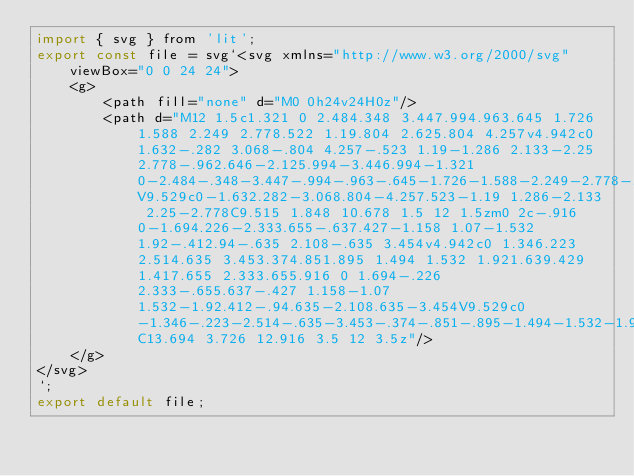Convert code to text. <code><loc_0><loc_0><loc_500><loc_500><_JavaScript_>import { svg } from 'lit';
export const file = svg`<svg xmlns="http://www.w3.org/2000/svg" viewBox="0 0 24 24">
    <g>
        <path fill="none" d="M0 0h24v24H0z"/>
        <path d="M12 1.5c1.321 0 2.484.348 3.447.994.963.645 1.726 1.588 2.249 2.778.522 1.19.804 2.625.804 4.257v4.942c0 1.632-.282 3.068-.804 4.257-.523 1.19-1.286 2.133-2.25 2.778-.962.646-2.125.994-3.446.994-1.321 0-2.484-.348-3.447-.994-.963-.645-1.726-1.588-2.249-2.778-.522-1.19-.804-2.625-.804-4.257V9.529c0-1.632.282-3.068.804-4.257.523-1.19 1.286-2.133 2.25-2.778C9.515 1.848 10.678 1.5 12 1.5zm0 2c-.916 0-1.694.226-2.333.655-.637.427-1.158 1.07-1.532 1.92-.412.94-.635 2.108-.635 3.454v4.942c0 1.346.223 2.514.635 3.453.374.851.895 1.494 1.532 1.921.639.429 1.417.655 2.333.655.916 0 1.694-.226 2.333-.655.637-.427 1.158-1.07 1.532-1.92.412-.94.635-2.108.635-3.454V9.529c0-1.346-.223-2.514-.635-3.453-.374-.851-.895-1.494-1.532-1.921C13.694 3.726 12.916 3.5 12 3.5z"/>
    </g>
</svg>
`;
export default file;</code> 